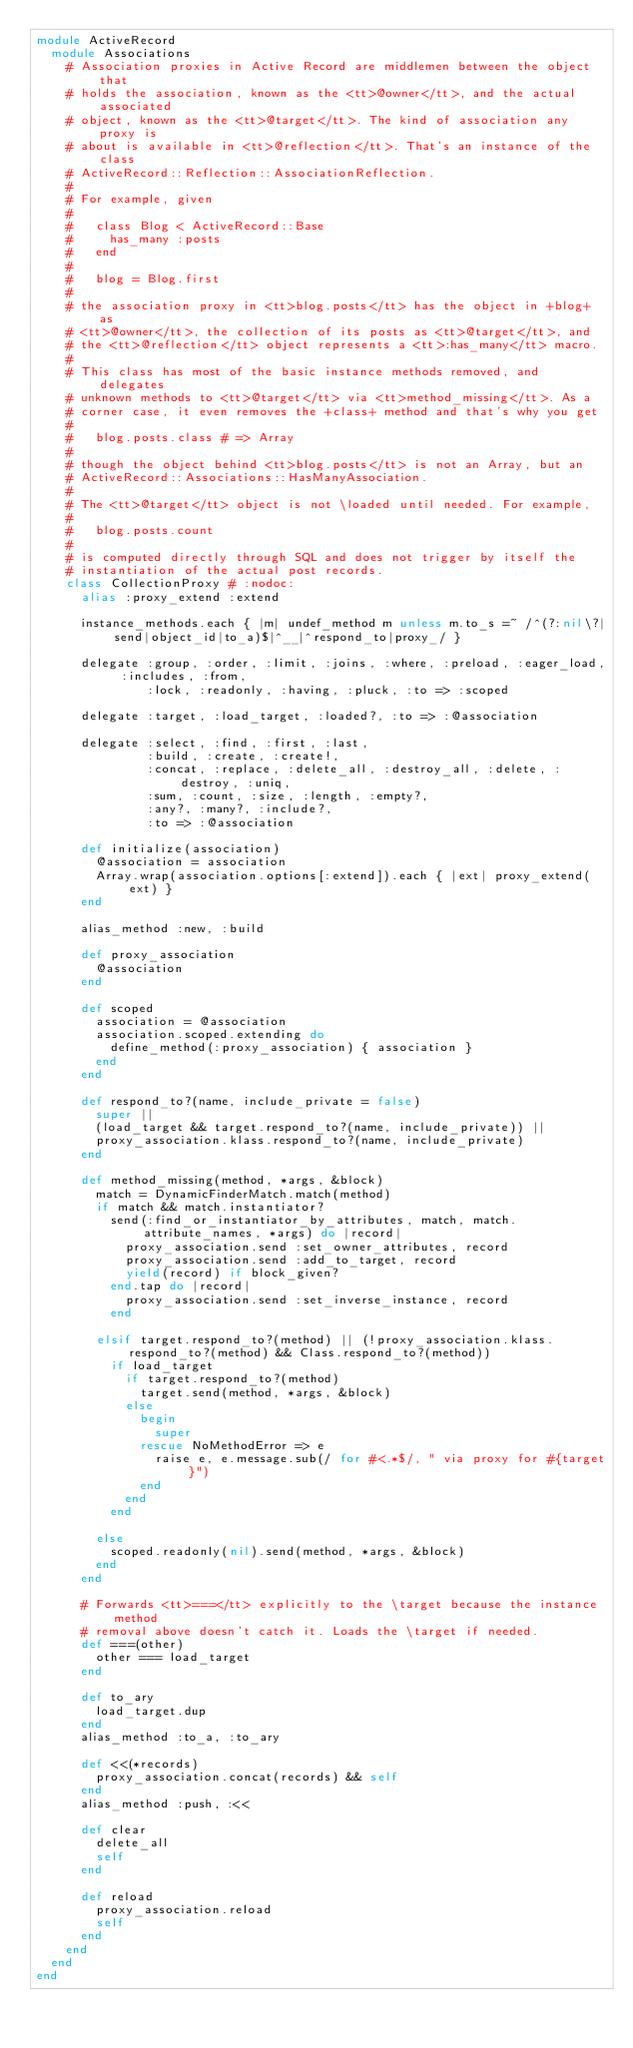Convert code to text. <code><loc_0><loc_0><loc_500><loc_500><_Ruby_>module ActiveRecord
  module Associations
    # Association proxies in Active Record are middlemen between the object that
    # holds the association, known as the <tt>@owner</tt>, and the actual associated
    # object, known as the <tt>@target</tt>. The kind of association any proxy is
    # about is available in <tt>@reflection</tt>. That's an instance of the class
    # ActiveRecord::Reflection::AssociationReflection.
    #
    # For example, given
    #
    #   class Blog < ActiveRecord::Base
    #     has_many :posts
    #   end
    #
    #   blog = Blog.first
    #
    # the association proxy in <tt>blog.posts</tt> has the object in +blog+ as
    # <tt>@owner</tt>, the collection of its posts as <tt>@target</tt>, and
    # the <tt>@reflection</tt> object represents a <tt>:has_many</tt> macro.
    #
    # This class has most of the basic instance methods removed, and delegates
    # unknown methods to <tt>@target</tt> via <tt>method_missing</tt>. As a
    # corner case, it even removes the +class+ method and that's why you get
    #
    #   blog.posts.class # => Array
    #
    # though the object behind <tt>blog.posts</tt> is not an Array, but an
    # ActiveRecord::Associations::HasManyAssociation.
    #
    # The <tt>@target</tt> object is not \loaded until needed. For example,
    #
    #   blog.posts.count
    #
    # is computed directly through SQL and does not trigger by itself the
    # instantiation of the actual post records.
    class CollectionProxy # :nodoc:
      alias :proxy_extend :extend

      instance_methods.each { |m| undef_method m unless m.to_s =~ /^(?:nil\?|send|object_id|to_a)$|^__|^respond_to|proxy_/ }

      delegate :group, :order, :limit, :joins, :where, :preload, :eager_load, :includes, :from,
               :lock, :readonly, :having, :pluck, :to => :scoped

      delegate :target, :load_target, :loaded?, :to => :@association

      delegate :select, :find, :first, :last,
               :build, :create, :create!,
               :concat, :replace, :delete_all, :destroy_all, :delete, :destroy, :uniq,
               :sum, :count, :size, :length, :empty?,
               :any?, :many?, :include?,
               :to => :@association

      def initialize(association)
        @association = association
        Array.wrap(association.options[:extend]).each { |ext| proxy_extend(ext) }
      end

      alias_method :new, :build

      def proxy_association
        @association
      end

      def scoped
        association = @association
        association.scoped.extending do
          define_method(:proxy_association) { association }
        end
      end

      def respond_to?(name, include_private = false)
        super ||
        (load_target && target.respond_to?(name, include_private)) ||
        proxy_association.klass.respond_to?(name, include_private)
      end

      def method_missing(method, *args, &block)
        match = DynamicFinderMatch.match(method)
        if match && match.instantiator?
          send(:find_or_instantiator_by_attributes, match, match.attribute_names, *args) do |record|
            proxy_association.send :set_owner_attributes, record
            proxy_association.send :add_to_target, record
            yield(record) if block_given?
          end.tap do |record|
            proxy_association.send :set_inverse_instance, record
          end

        elsif target.respond_to?(method) || (!proxy_association.klass.respond_to?(method) && Class.respond_to?(method))
          if load_target
            if target.respond_to?(method)
              target.send(method, *args, &block)
            else
              begin
                super
              rescue NoMethodError => e
                raise e, e.message.sub(/ for #<.*$/, " via proxy for #{target}")
              end
            end
          end

        else
          scoped.readonly(nil).send(method, *args, &block)
        end
      end

      # Forwards <tt>===</tt> explicitly to the \target because the instance method
      # removal above doesn't catch it. Loads the \target if needed.
      def ===(other)
        other === load_target
      end

      def to_ary
        load_target.dup
      end
      alias_method :to_a, :to_ary

      def <<(*records)
        proxy_association.concat(records) && self
      end
      alias_method :push, :<<

      def clear
        delete_all
        self
      end

      def reload
        proxy_association.reload
        self
      end
    end
  end
end
</code> 